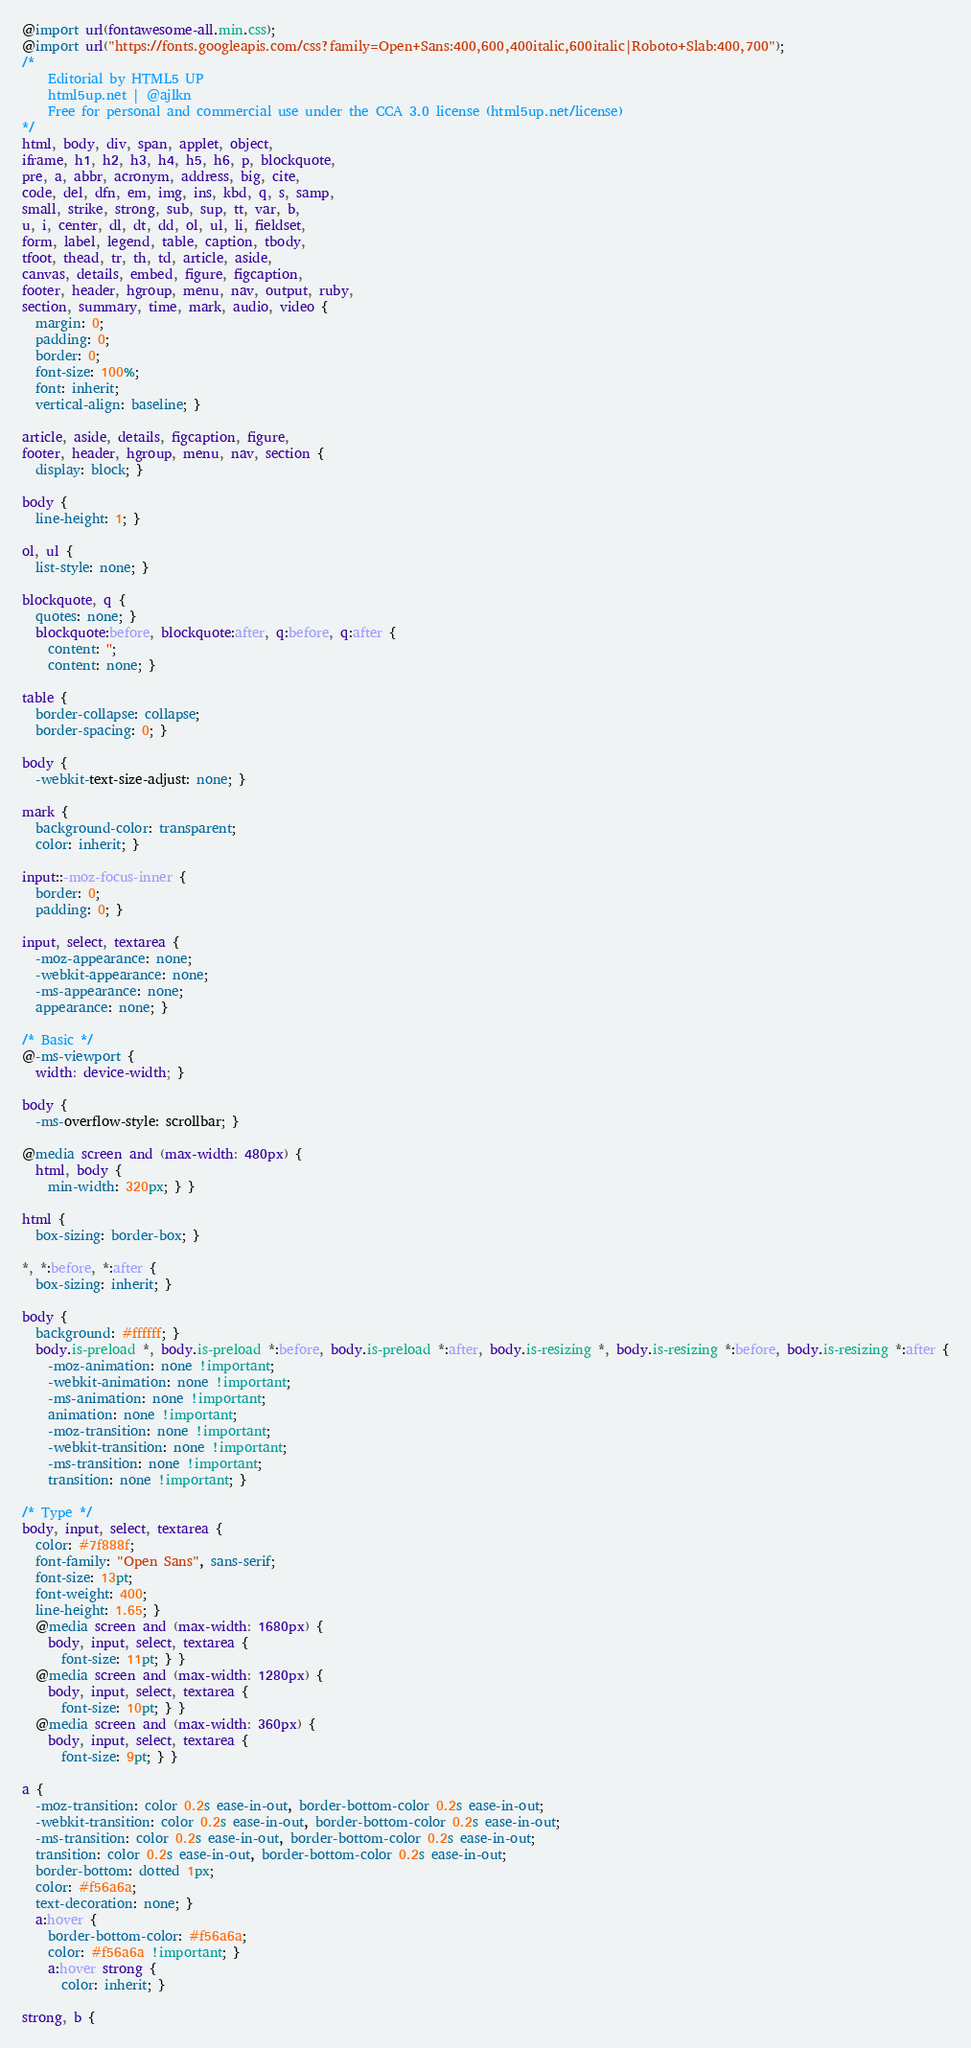Convert code to text. <code><loc_0><loc_0><loc_500><loc_500><_CSS_>@import url(fontawesome-all.min.css);
@import url("https://fonts.googleapis.com/css?family=Open+Sans:400,600,400italic,600italic|Roboto+Slab:400,700");
/*
	Editorial by HTML5 UP
	html5up.net | @ajlkn
	Free for personal and commercial use under the CCA 3.0 license (html5up.net/license)
*/
html, body, div, span, applet, object,
iframe, h1, h2, h3, h4, h5, h6, p, blockquote,
pre, a, abbr, acronym, address, big, cite,
code, del, dfn, em, img, ins, kbd, q, s, samp,
small, strike, strong, sub, sup, tt, var, b,
u, i, center, dl, dt, dd, ol, ul, li, fieldset,
form, label, legend, table, caption, tbody,
tfoot, thead, tr, th, td, article, aside,
canvas, details, embed, figure, figcaption,
footer, header, hgroup, menu, nav, output, ruby,
section, summary, time, mark, audio, video {
  margin: 0;
  padding: 0;
  border: 0;
  font-size: 100%;
  font: inherit;
  vertical-align: baseline; }

article, aside, details, figcaption, figure,
footer, header, hgroup, menu, nav, section {
  display: block; }

body {
  line-height: 1; }

ol, ul {
  list-style: none; }

blockquote, q {
  quotes: none; }
  blockquote:before, blockquote:after, q:before, q:after {
    content: '';
    content: none; }

table {
  border-collapse: collapse;
  border-spacing: 0; }

body {
  -webkit-text-size-adjust: none; }

mark {
  background-color: transparent;
  color: inherit; }

input::-moz-focus-inner {
  border: 0;
  padding: 0; }

input, select, textarea {
  -moz-appearance: none;
  -webkit-appearance: none;
  -ms-appearance: none;
  appearance: none; }

/* Basic */
@-ms-viewport {
  width: device-width; }

body {
  -ms-overflow-style: scrollbar; }

@media screen and (max-width: 480px) {
  html, body {
    min-width: 320px; } }

html {
  box-sizing: border-box; }

*, *:before, *:after {
  box-sizing: inherit; }

body {
  background: #ffffff; }
  body.is-preload *, body.is-preload *:before, body.is-preload *:after, body.is-resizing *, body.is-resizing *:before, body.is-resizing *:after {
    -moz-animation: none !important;
    -webkit-animation: none !important;
    -ms-animation: none !important;
    animation: none !important;
    -moz-transition: none !important;
    -webkit-transition: none !important;
    -ms-transition: none !important;
    transition: none !important; }

/* Type */
body, input, select, textarea {
  color: #7f888f;
  font-family: "Open Sans", sans-serif;
  font-size: 13pt;
  font-weight: 400;
  line-height: 1.65; }
  @media screen and (max-width: 1680px) {
    body, input, select, textarea {
      font-size: 11pt; } }
  @media screen and (max-width: 1280px) {
    body, input, select, textarea {
      font-size: 10pt; } }
  @media screen and (max-width: 360px) {
    body, input, select, textarea {
      font-size: 9pt; } }

a {
  -moz-transition: color 0.2s ease-in-out, border-bottom-color 0.2s ease-in-out;
  -webkit-transition: color 0.2s ease-in-out, border-bottom-color 0.2s ease-in-out;
  -ms-transition: color 0.2s ease-in-out, border-bottom-color 0.2s ease-in-out;
  transition: color 0.2s ease-in-out, border-bottom-color 0.2s ease-in-out;
  border-bottom: dotted 1px;
  color: #f56a6a;
  text-decoration: none; }
  a:hover {
    border-bottom-color: #f56a6a;
    color: #f56a6a !important; }
    a:hover strong {
      color: inherit; }

strong, b {</code> 